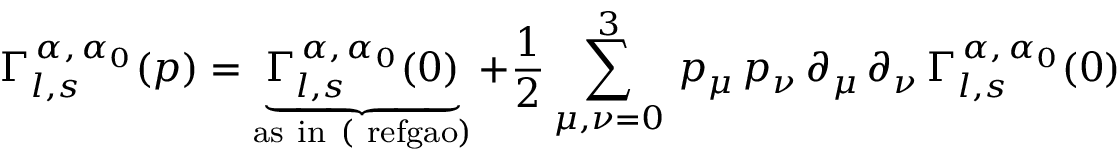Convert formula to latex. <formula><loc_0><loc_0><loc_500><loc_500>\Gamma _ { l , s } ^ { \, \alpha , \, \alpha _ { 0 } } ( p ) = \underbrace { \Gamma _ { l , s } ^ { \, \alpha , \, \alpha _ { 0 } } ( 0 ) } _ { { a s \ i n \ ( \ r e f { g a o } } ) } + \frac { 1 } { 2 } \sum _ { \mu , \nu = 0 } ^ { 3 } \, p _ { \mu } \, p _ { \nu } \, \partial _ { \mu } \, \partial _ { \nu } \, \Gamma _ { l , s } ^ { \, \alpha , \, \alpha _ { 0 } } ( 0 )</formula> 